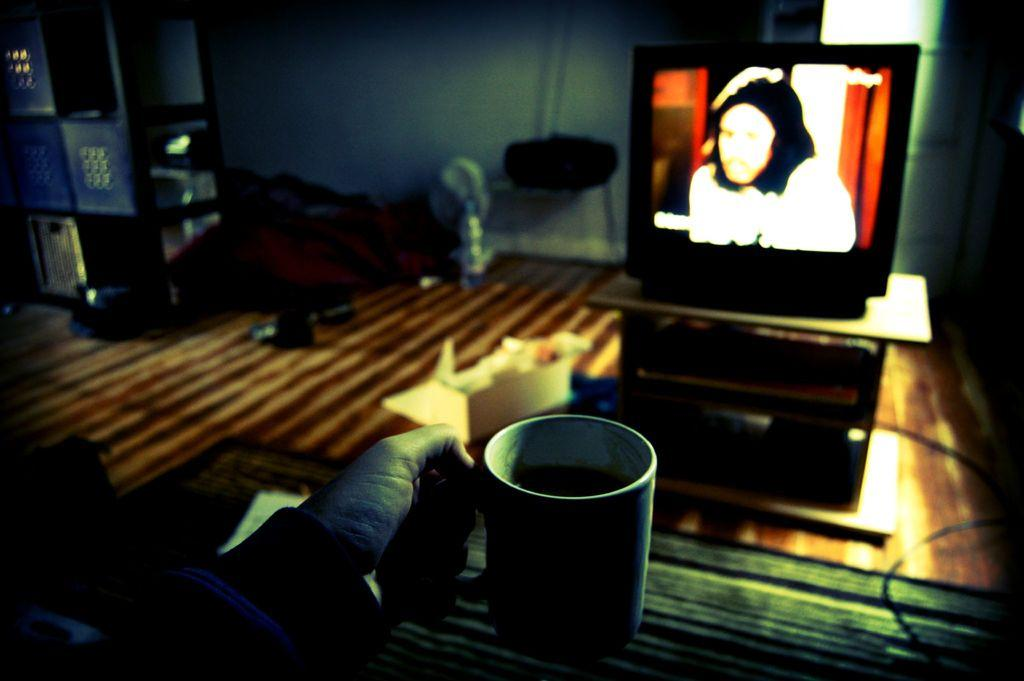What is the person in the image holding? The person is holding a cup in the image. What is on the table in the image? There is a television on the table in the image. What is the background of the image? There is a wall in the background of the image. What can be seen beneath the table and television? The floor is visible in the image. What type of knowledge can be gained from the jar in the image? There is no jar present in the image, so no knowledge can be gained from it. 